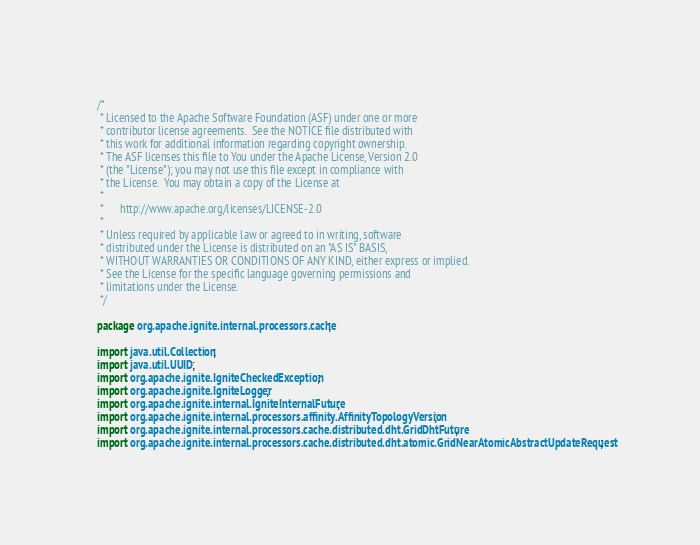<code> <loc_0><loc_0><loc_500><loc_500><_Java_>/*
 * Licensed to the Apache Software Foundation (ASF) under one or more
 * contributor license agreements.  See the NOTICE file distributed with
 * this work for additional information regarding copyright ownership.
 * The ASF licenses this file to You under the Apache License, Version 2.0
 * (the "License"); you may not use this file except in compliance with
 * the License.  You may obtain a copy of the License at
 *
 *      http://www.apache.org/licenses/LICENSE-2.0
 *
 * Unless required by applicable law or agreed to in writing, software
 * distributed under the License is distributed on an "AS IS" BASIS,
 * WITHOUT WARRANTIES OR CONDITIONS OF ANY KIND, either express or implied.
 * See the License for the specific language governing permissions and
 * limitations under the License.
 */

package org.apache.ignite.internal.processors.cache;

import java.util.Collection;
import java.util.UUID;
import org.apache.ignite.IgniteCheckedException;
import org.apache.ignite.IgniteLogger;
import org.apache.ignite.internal.IgniteInternalFuture;
import org.apache.ignite.internal.processors.affinity.AffinityTopologyVersion;
import org.apache.ignite.internal.processors.cache.distributed.dht.GridDhtFuture;
import org.apache.ignite.internal.processors.cache.distributed.dht.atomic.GridNearAtomicAbstractUpdateRequest;</code> 